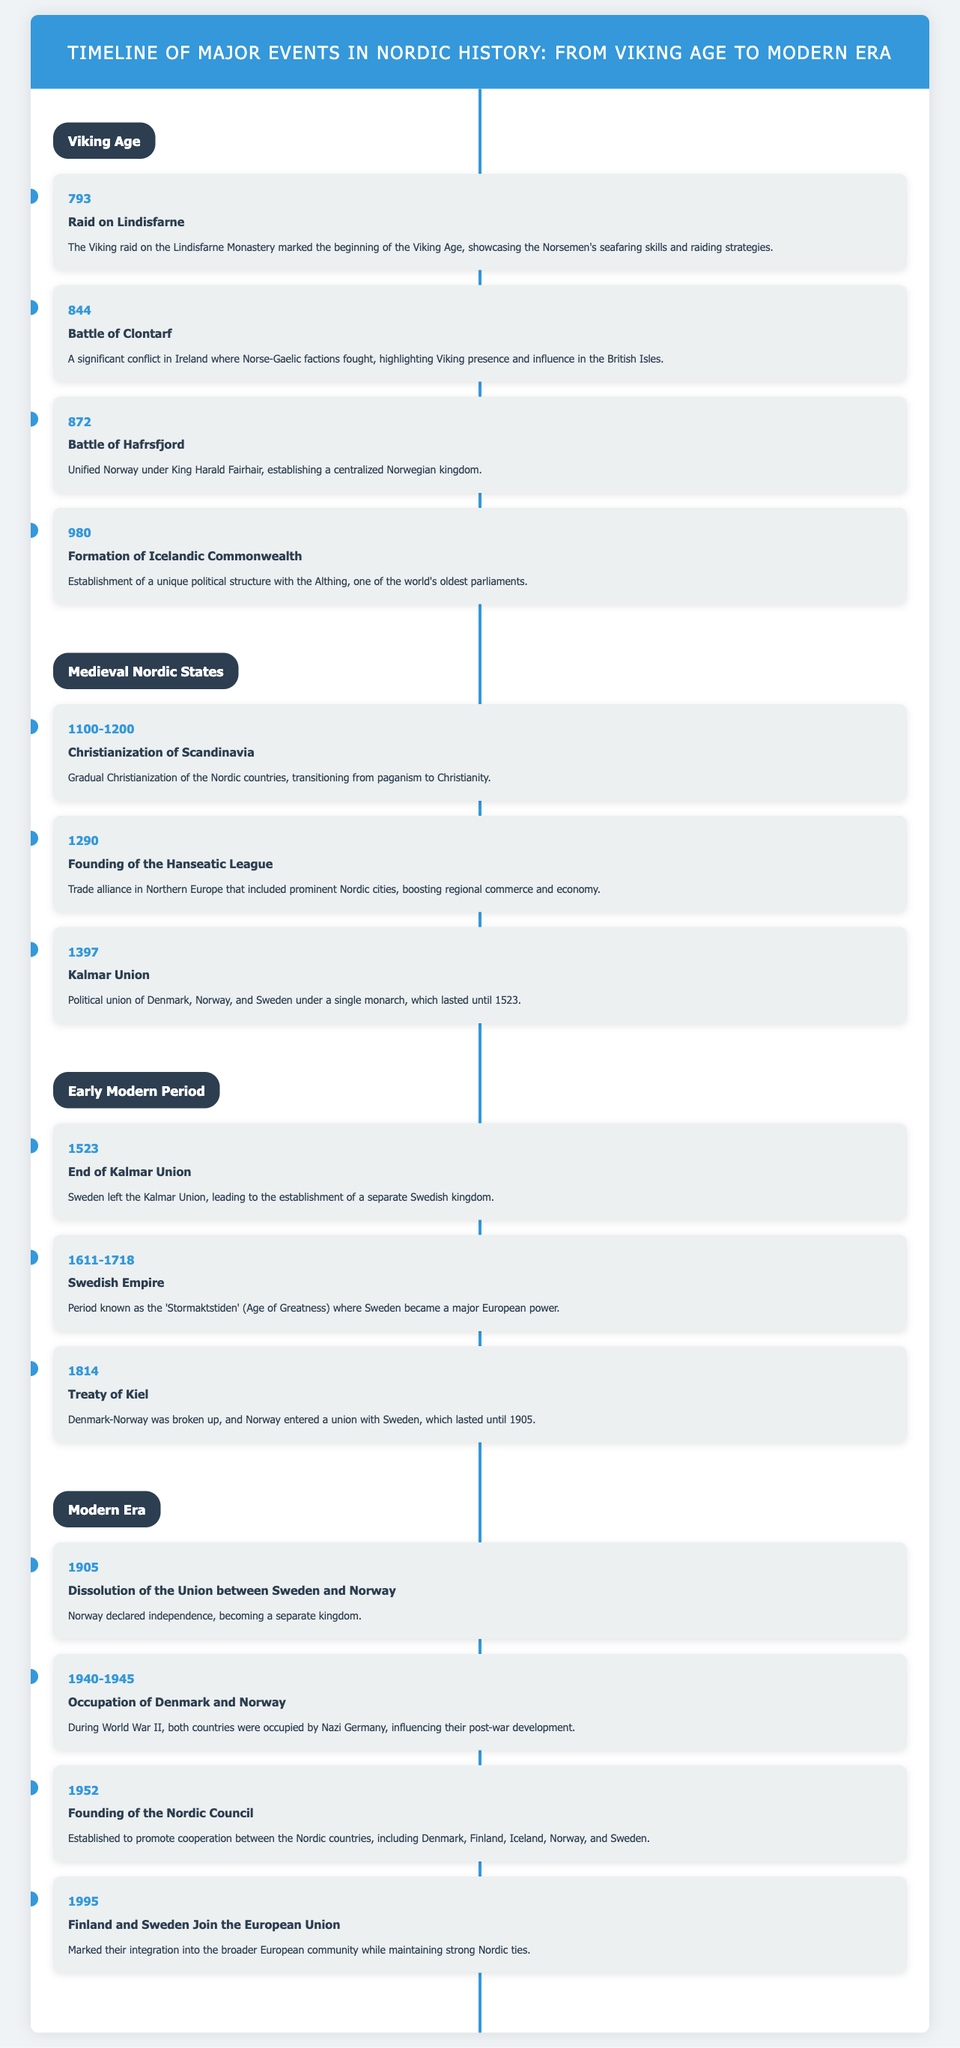What year did the raid on Lindisfarne occur? The raid on Lindisfarne is listed in the Viking Age events as occurring in the year 793.
Answer: 793 What was established in 980? The event in 980 describes the formation of the Icelandic Commonwealth, which is a significant political structure.
Answer: Formation of Icelandic Commonwealth What years did the Swedish Empire exist? The timeline states that the Swedish Empire lasted from 1611 to 1718.
Answer: 1611-1718 What was the outcome of the Treaty of Kiel in 1814? The event outlines that Denmark-Norway was broken up and Norway entered a union with Sweden.
Answer: Union with Sweden What event led to Norwegian independence in 1905? The dissolution of the Union between Sweden and Norway is the event that led to Norway declaring independence.
Answer: Dissolution of the Union What significant alliance was founded in 1290? The document highlights the founding of the Hanseatic League as a trade alliance in Northern Europe.
Answer: Hanseatic League What marked the end of the Kalmar Union? The timeline indicates that Sweden leaving the Kalmar Union in 1523 marks its end.
Answer: End of Kalmar Union What event does 1952 signify in Nordic cooperation? In 1952, the founding of the Nordic Council took place to promote cooperation between the Nordic countries.
Answer: Founding of the Nordic Council What major global event occurred in Denmark and Norway from 1940 to 1945? The timeline notes the occupation of Denmark and Norway during World War II.
Answer: World War II 